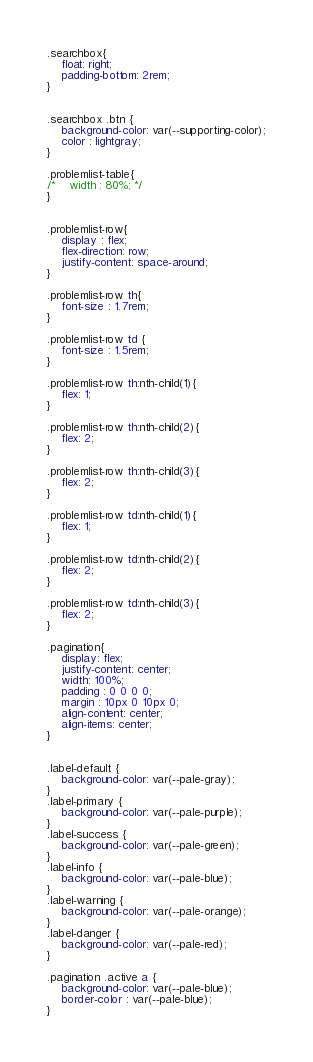Convert code to text. <code><loc_0><loc_0><loc_500><loc_500><_CSS_>
.searchbox{
    float: right; 
    padding-bottom: 2rem;
}


.searchbox .btn {
    background-color: var(--supporting-color);
    color : lightgray;
}

.problemlist-table{
/*    width : 80%; */ 
}


.problemlist-row{
    display : flex; 
    flex-direction: row;
    justify-content: space-around;
}

.problemlist-row th{
    font-size : 1.7rem; 
}

.problemlist-row td {
    font-size : 1.5rem; 
}

.problemlist-row th:nth-child(1){
    flex: 1;
}

.problemlist-row th:nth-child(2){
    flex: 2;
}

.problemlist-row th:nth-child(3){
    flex: 2;
}

.problemlist-row td:nth-child(1){
    flex: 1;
}

.problemlist-row td:nth-child(2){
    flex: 2;
}

.problemlist-row td:nth-child(3){
    flex: 2;
}

.pagination{
    display: flex;
    justify-content: center;
    width: 100%;
    padding : 0 0 0 0; 
    margin : 10px 0 10px 0; 
    align-content: center;
    align-items: center;
}


.label-default {
    background-color: var(--pale-gray); 
}
.label-primary {
    background-color: var(--pale-purple); 
}
.label-success {
    background-color: var(--pale-green);
}
.label-info {
    background-color: var(--pale-blue); 
}
.label-warning {
    background-color: var(--pale-orange);
}
.label-danger {
    background-color: var(--pale-red);
}

.pagination .active a {
    background-color: var(--pale-blue);
    border-color : var(--pale-blue);
}</code> 